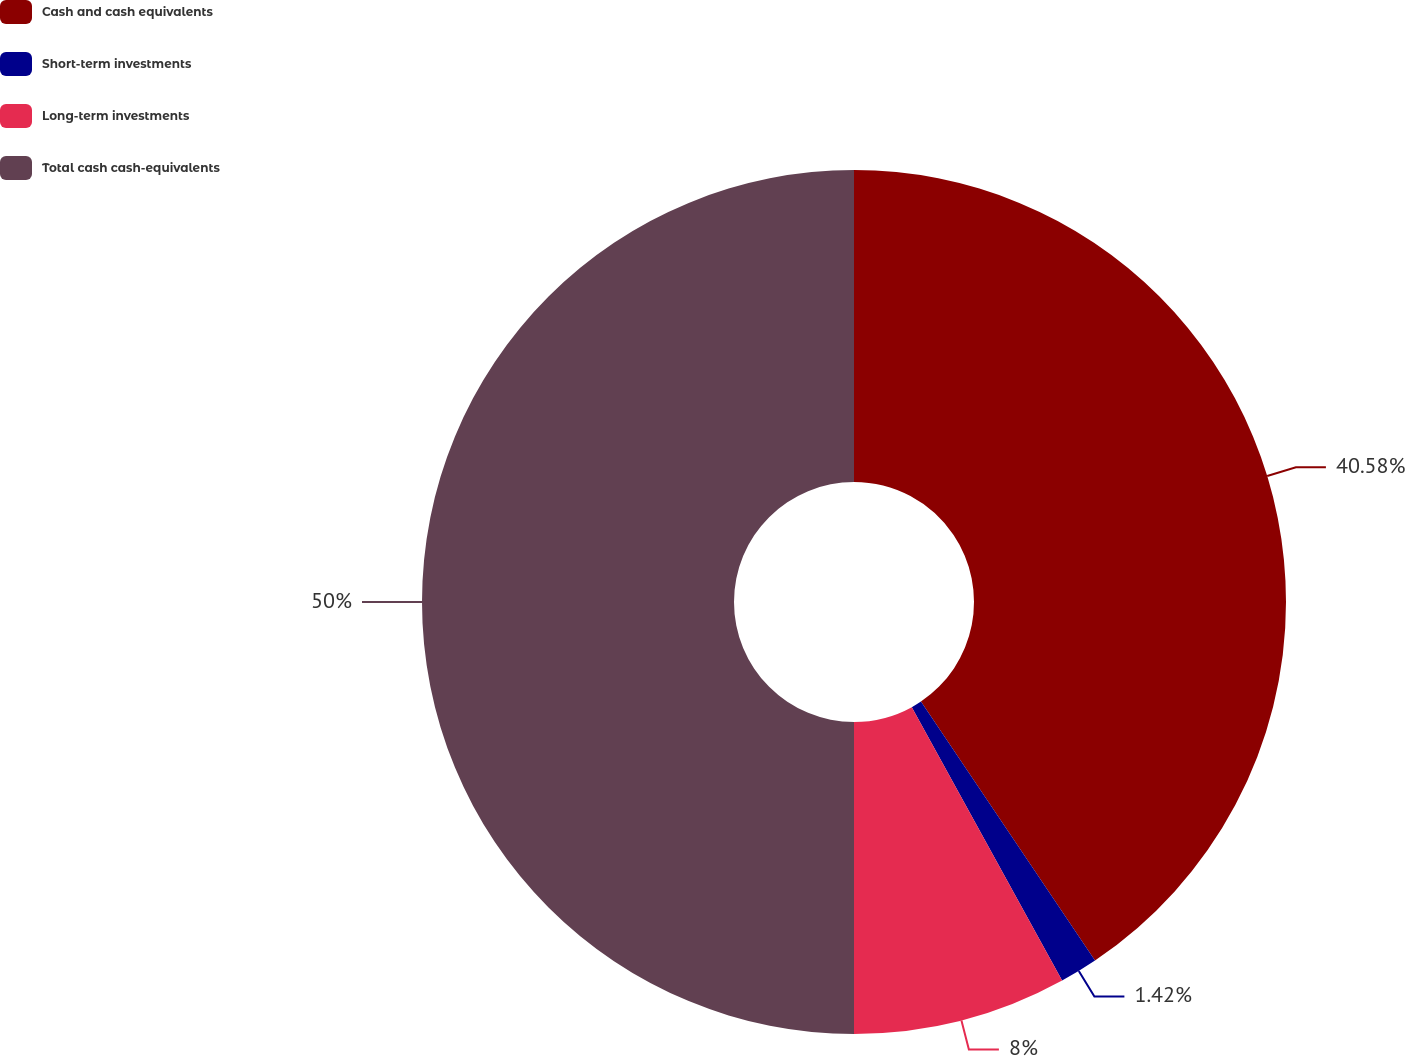Convert chart to OTSL. <chart><loc_0><loc_0><loc_500><loc_500><pie_chart><fcel>Cash and cash equivalents<fcel>Short-term investments<fcel>Long-term investments<fcel>Total cash cash-equivalents<nl><fcel>40.58%<fcel>1.42%<fcel>8.0%<fcel>50.0%<nl></chart> 